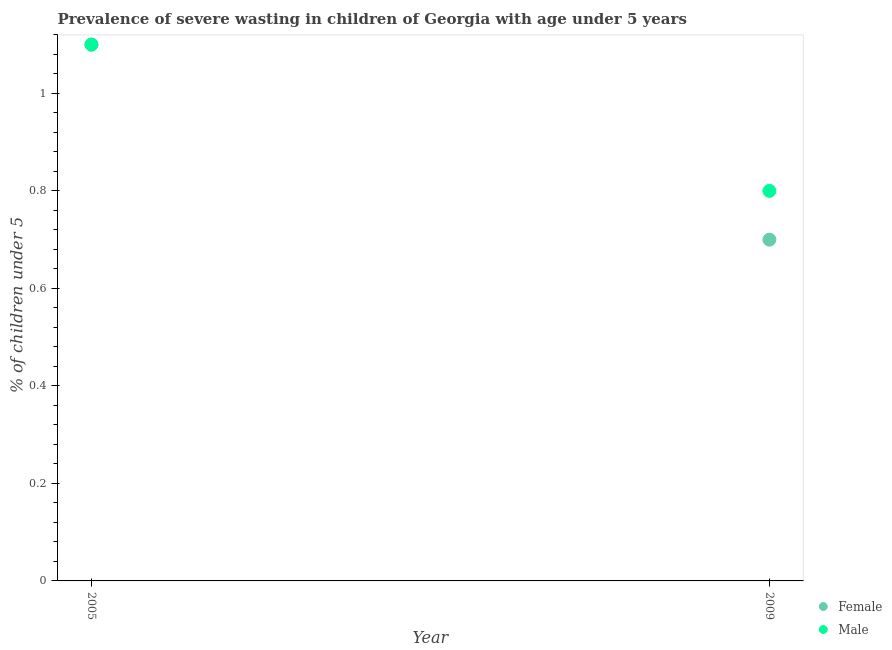Is the number of dotlines equal to the number of legend labels?
Your response must be concise. Yes. What is the percentage of undernourished male children in 2005?
Ensure brevity in your answer.  1.1. Across all years, what is the maximum percentage of undernourished male children?
Give a very brief answer. 1.1. Across all years, what is the minimum percentage of undernourished female children?
Ensure brevity in your answer.  0.7. In which year was the percentage of undernourished female children maximum?
Provide a short and direct response. 2005. What is the total percentage of undernourished female children in the graph?
Make the answer very short. 1.8. What is the difference between the percentage of undernourished male children in 2005 and that in 2009?
Your response must be concise. 0.3. What is the difference between the percentage of undernourished female children in 2009 and the percentage of undernourished male children in 2005?
Offer a very short reply. -0.4. What is the average percentage of undernourished female children per year?
Offer a very short reply. 0.9. In the year 2009, what is the difference between the percentage of undernourished female children and percentage of undernourished male children?
Offer a terse response. -0.1. In how many years, is the percentage of undernourished male children greater than 0.8 %?
Your answer should be compact. 2. What is the ratio of the percentage of undernourished male children in 2005 to that in 2009?
Your answer should be very brief. 1.38. Is the percentage of undernourished female children in 2005 less than that in 2009?
Provide a short and direct response. No. In how many years, is the percentage of undernourished female children greater than the average percentage of undernourished female children taken over all years?
Your answer should be compact. 1. Is the percentage of undernourished male children strictly greater than the percentage of undernourished female children over the years?
Your answer should be compact. No. Is the percentage of undernourished female children strictly less than the percentage of undernourished male children over the years?
Make the answer very short. No. Does the graph contain any zero values?
Provide a succinct answer. No. Does the graph contain grids?
Your answer should be compact. No. Where does the legend appear in the graph?
Give a very brief answer. Bottom right. How many legend labels are there?
Your answer should be compact. 2. What is the title of the graph?
Your response must be concise. Prevalence of severe wasting in children of Georgia with age under 5 years. Does "From human activities" appear as one of the legend labels in the graph?
Your answer should be very brief. No. What is the label or title of the X-axis?
Provide a short and direct response. Year. What is the label or title of the Y-axis?
Provide a short and direct response.  % of children under 5. What is the  % of children under 5 of Female in 2005?
Keep it short and to the point. 1.1. What is the  % of children under 5 in Male in 2005?
Your response must be concise. 1.1. What is the  % of children under 5 of Female in 2009?
Your response must be concise. 0.7. What is the  % of children under 5 in Male in 2009?
Give a very brief answer. 0.8. Across all years, what is the maximum  % of children under 5 in Female?
Your response must be concise. 1.1. Across all years, what is the maximum  % of children under 5 in Male?
Make the answer very short. 1.1. Across all years, what is the minimum  % of children under 5 of Female?
Your answer should be very brief. 0.7. Across all years, what is the minimum  % of children under 5 of Male?
Your answer should be very brief. 0.8. What is the difference between the  % of children under 5 in Female in 2005 and that in 2009?
Your answer should be very brief. 0.4. What is the difference between the  % of children under 5 in Male in 2005 and that in 2009?
Give a very brief answer. 0.3. In the year 2005, what is the difference between the  % of children under 5 in Female and  % of children under 5 in Male?
Make the answer very short. 0. What is the ratio of the  % of children under 5 in Female in 2005 to that in 2009?
Give a very brief answer. 1.57. What is the ratio of the  % of children under 5 in Male in 2005 to that in 2009?
Your answer should be compact. 1.38. What is the difference between the highest and the lowest  % of children under 5 in Female?
Give a very brief answer. 0.4. 